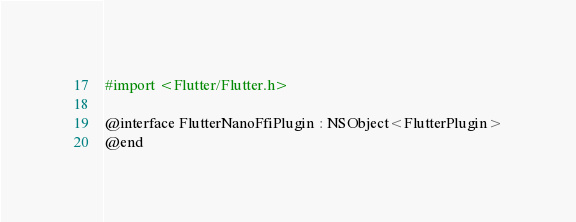Convert code to text. <code><loc_0><loc_0><loc_500><loc_500><_C_>#import <Flutter/Flutter.h>

@interface FlutterNanoFfiPlugin : NSObject<FlutterPlugin>
@end
</code> 